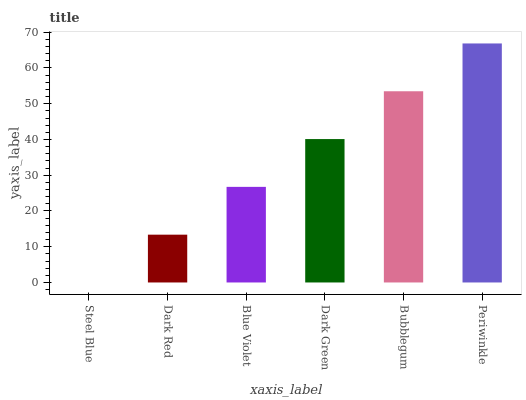Is Dark Red the minimum?
Answer yes or no. No. Is Dark Red the maximum?
Answer yes or no. No. Is Dark Red greater than Steel Blue?
Answer yes or no. Yes. Is Steel Blue less than Dark Red?
Answer yes or no. Yes. Is Steel Blue greater than Dark Red?
Answer yes or no. No. Is Dark Red less than Steel Blue?
Answer yes or no. No. Is Dark Green the high median?
Answer yes or no. Yes. Is Blue Violet the low median?
Answer yes or no. Yes. Is Bubblegum the high median?
Answer yes or no. No. Is Dark Red the low median?
Answer yes or no. No. 